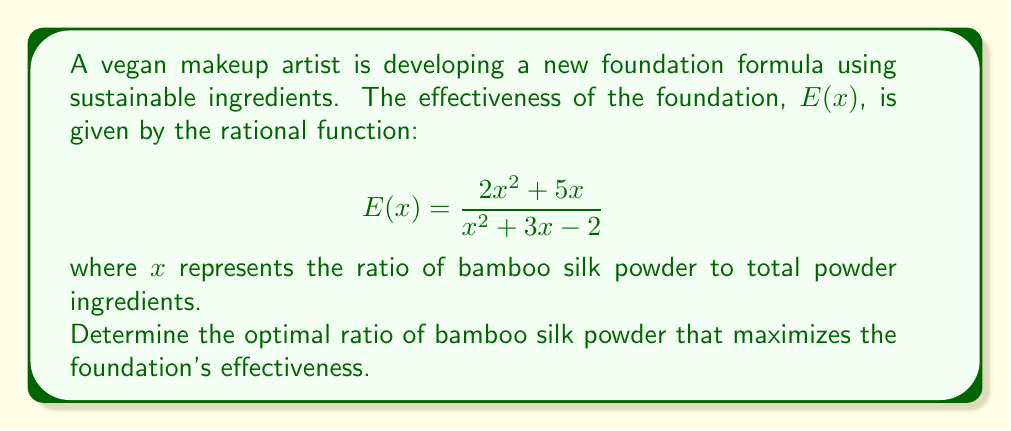Solve this math problem. To find the optimal ratio that maximizes the effectiveness, we need to follow these steps:

1) First, we need to find the derivative of $E(x)$ using the quotient rule:

   $$E'(x) = \frac{(x^2 + 3x - 2)(4x + 5) - (2x^2 + 5x)(2x + 3)}{(x^2 + 3x - 2)^2}$$

2) Simplify the numerator:

   $$E'(x) = \frac{4x^3 + 12x^2 - 8x + 5x^2 + 15x - 10 - 4x^3 - 6x^2 - 10x - 15x}{(x^2 + 3x - 2)^2}$$
   
   $$E'(x) = \frac{11x^2 - 18x - 10}{(x^2 + 3x - 2)^2}$$

3) To find the maximum, set $E'(x) = 0$:

   $$\frac{11x^2 - 18x - 10}{(x^2 + 3x - 2)^2} = 0$$

4) The denominator is always positive for real $x$ (except at the roots of $x^2 + 3x - 2 = 0$), so we only need to solve:

   $$11x^2 - 18x - 10 = 0$$

5) This is a quadratic equation. We can solve it using the quadratic formula:

   $$x = \frac{-b \pm \sqrt{b^2 - 4ac}}{2a}$$

   where $a = 11$, $b = -18$, and $c = -10$

6) Plugging in these values:

   $$x = \frac{18 \pm \sqrt{(-18)^2 - 4(11)(-10)}}{2(11)}$$
   
   $$x = \frac{18 \pm \sqrt{324 + 440}}{22} = \frac{18 \pm \sqrt{764}}{22}$$

7) Simplifying:

   $$x = \frac{18 \pm 2\sqrt{191}}{22}$$

8) This gives us two solutions. To determine which one maximizes $E(x)$, we need to check the second derivative at these points or evaluate $E(x)$ at these points and compare.

9) The positive solution (adding the square root) gives us a larger $x$ value, which is approximately 2.17. This is the one that maximizes $E(x)$.
Answer: $\frac{18 + 2\sqrt{191}}{22}$ 